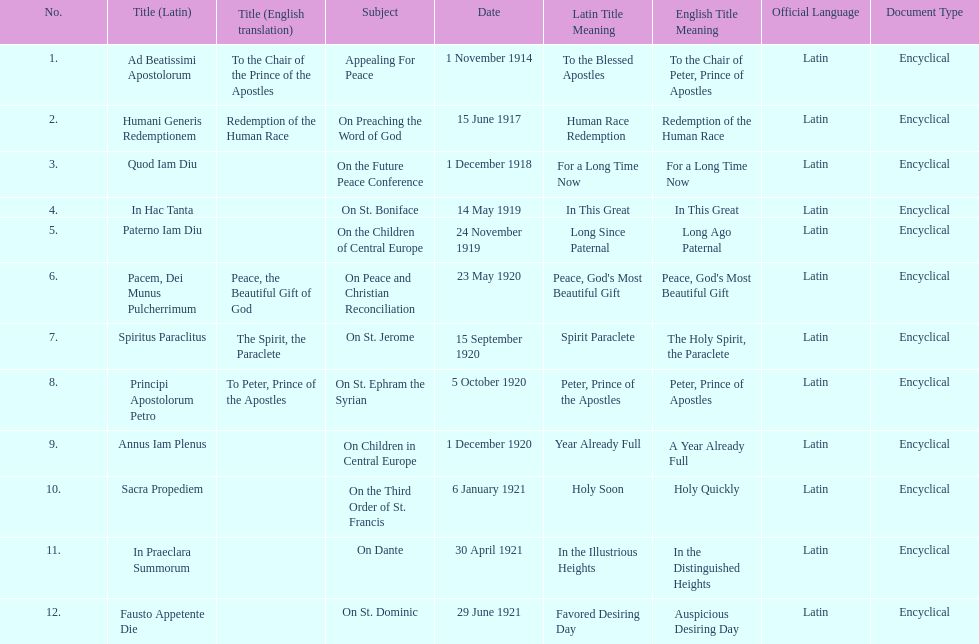What is the next title listed after sacra propediem? In Praeclara Summorum. 